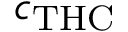Convert formula to latex. <formula><loc_0><loc_0><loc_500><loc_500>c _ { T H C }</formula> 